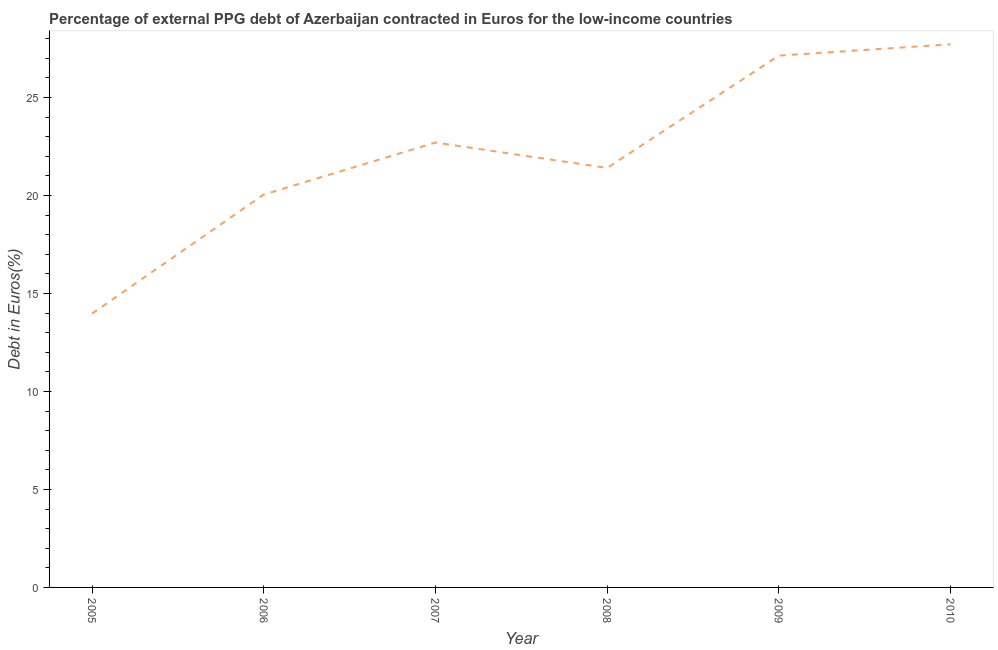What is the currency composition of ppg debt in 2006?
Provide a succinct answer. 20.05. Across all years, what is the maximum currency composition of ppg debt?
Your answer should be compact. 27.71. Across all years, what is the minimum currency composition of ppg debt?
Ensure brevity in your answer.  13.97. In which year was the currency composition of ppg debt minimum?
Your response must be concise. 2005. What is the sum of the currency composition of ppg debt?
Offer a very short reply. 132.96. What is the difference between the currency composition of ppg debt in 2006 and 2007?
Offer a very short reply. -2.65. What is the average currency composition of ppg debt per year?
Provide a short and direct response. 22.16. What is the median currency composition of ppg debt?
Provide a short and direct response. 22.05. In how many years, is the currency composition of ppg debt greater than 12 %?
Offer a terse response. 6. Do a majority of the years between 2009 and 2008 (inclusive) have currency composition of ppg debt greater than 9 %?
Your answer should be compact. No. What is the ratio of the currency composition of ppg debt in 2005 to that in 2008?
Ensure brevity in your answer.  0.65. What is the difference between the highest and the second highest currency composition of ppg debt?
Ensure brevity in your answer.  0.58. Is the sum of the currency composition of ppg debt in 2008 and 2010 greater than the maximum currency composition of ppg debt across all years?
Make the answer very short. Yes. What is the difference between the highest and the lowest currency composition of ppg debt?
Make the answer very short. 13.74. In how many years, is the currency composition of ppg debt greater than the average currency composition of ppg debt taken over all years?
Ensure brevity in your answer.  3. How many lines are there?
Your response must be concise. 1. Are the values on the major ticks of Y-axis written in scientific E-notation?
Ensure brevity in your answer.  No. Does the graph contain any zero values?
Provide a short and direct response. No. Does the graph contain grids?
Your answer should be very brief. No. What is the title of the graph?
Your response must be concise. Percentage of external PPG debt of Azerbaijan contracted in Euros for the low-income countries. What is the label or title of the X-axis?
Your answer should be compact. Year. What is the label or title of the Y-axis?
Offer a very short reply. Debt in Euros(%). What is the Debt in Euros(%) in 2005?
Provide a short and direct response. 13.97. What is the Debt in Euros(%) in 2006?
Give a very brief answer. 20.05. What is the Debt in Euros(%) of 2007?
Offer a very short reply. 22.7. What is the Debt in Euros(%) of 2008?
Offer a terse response. 21.4. What is the Debt in Euros(%) in 2009?
Give a very brief answer. 27.13. What is the Debt in Euros(%) of 2010?
Ensure brevity in your answer.  27.71. What is the difference between the Debt in Euros(%) in 2005 and 2006?
Offer a terse response. -6.07. What is the difference between the Debt in Euros(%) in 2005 and 2007?
Your answer should be compact. -8.73. What is the difference between the Debt in Euros(%) in 2005 and 2008?
Your response must be concise. -7.43. What is the difference between the Debt in Euros(%) in 2005 and 2009?
Provide a short and direct response. -13.16. What is the difference between the Debt in Euros(%) in 2005 and 2010?
Provide a short and direct response. -13.74. What is the difference between the Debt in Euros(%) in 2006 and 2007?
Your answer should be compact. -2.65. What is the difference between the Debt in Euros(%) in 2006 and 2008?
Ensure brevity in your answer.  -1.36. What is the difference between the Debt in Euros(%) in 2006 and 2009?
Your answer should be compact. -7.09. What is the difference between the Debt in Euros(%) in 2006 and 2010?
Give a very brief answer. -7.67. What is the difference between the Debt in Euros(%) in 2007 and 2008?
Your answer should be compact. 1.3. What is the difference between the Debt in Euros(%) in 2007 and 2009?
Ensure brevity in your answer.  -4.43. What is the difference between the Debt in Euros(%) in 2007 and 2010?
Offer a terse response. -5.01. What is the difference between the Debt in Euros(%) in 2008 and 2009?
Give a very brief answer. -5.73. What is the difference between the Debt in Euros(%) in 2008 and 2010?
Give a very brief answer. -6.31. What is the difference between the Debt in Euros(%) in 2009 and 2010?
Make the answer very short. -0.58. What is the ratio of the Debt in Euros(%) in 2005 to that in 2006?
Provide a short and direct response. 0.7. What is the ratio of the Debt in Euros(%) in 2005 to that in 2007?
Provide a succinct answer. 0.62. What is the ratio of the Debt in Euros(%) in 2005 to that in 2008?
Your response must be concise. 0.65. What is the ratio of the Debt in Euros(%) in 2005 to that in 2009?
Provide a succinct answer. 0.52. What is the ratio of the Debt in Euros(%) in 2005 to that in 2010?
Make the answer very short. 0.5. What is the ratio of the Debt in Euros(%) in 2006 to that in 2007?
Offer a very short reply. 0.88. What is the ratio of the Debt in Euros(%) in 2006 to that in 2008?
Your answer should be compact. 0.94. What is the ratio of the Debt in Euros(%) in 2006 to that in 2009?
Offer a terse response. 0.74. What is the ratio of the Debt in Euros(%) in 2006 to that in 2010?
Provide a short and direct response. 0.72. What is the ratio of the Debt in Euros(%) in 2007 to that in 2008?
Offer a terse response. 1.06. What is the ratio of the Debt in Euros(%) in 2007 to that in 2009?
Make the answer very short. 0.84. What is the ratio of the Debt in Euros(%) in 2007 to that in 2010?
Offer a terse response. 0.82. What is the ratio of the Debt in Euros(%) in 2008 to that in 2009?
Provide a succinct answer. 0.79. What is the ratio of the Debt in Euros(%) in 2008 to that in 2010?
Give a very brief answer. 0.77. 